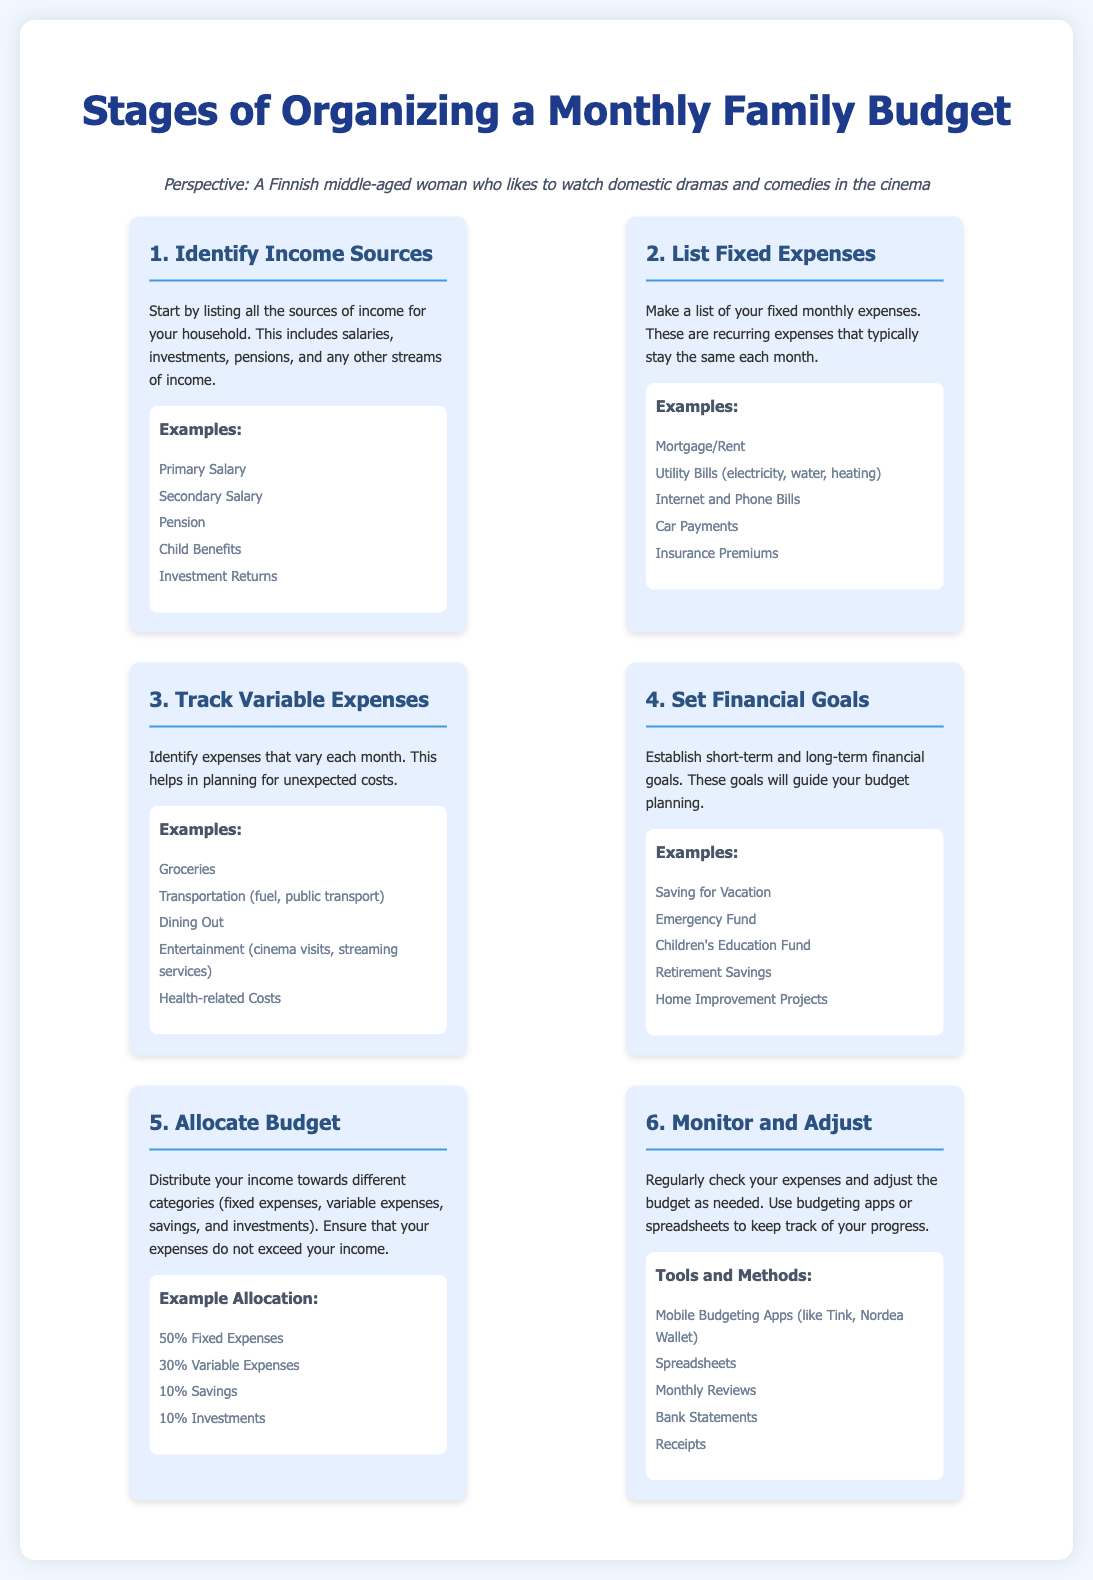what is the first stage of organizing a budget? The first stage listed in the document is to identify income sources.
Answer: Identify Income Sources what percentage of the budget should be allocated to fixed expenses? The document specifies that 50% of the budget should go to fixed expenses.
Answer: 50% name one example of a variable expense. The document provides several examples, one of which is groceries.
Answer: Groceries what is one tool mentioned for monitoring expenses? The document lists various tools, one being mobile budgeting apps.
Answer: Mobile Budgeting Apps how many stages are there in organizing a monthly family budget? The document outlines six distinct stages involved in the budgeting process.
Answer: Six what is the purpose of setting financial goals in budgeting? Setting financial goals helps guide the budget planning process.
Answer: Guide budget planning what percentage of the budget should be allocated to savings? According to the document, 10% of the budget should be allocated to savings.
Answer: 10% name an example of a fixed expense. One example of a fixed expense mentioned in the document is mortgage or rent.
Answer: Mortgage/Rent why is it important to track variable expenses? Tracking variable expenses helps in planning for unexpected costs.
Answer: Plan for unexpected costs what is the final stage in the budgeting process? The last stage in the document is to monitor and adjust the budget as necessary.
Answer: Monitor and Adjust 